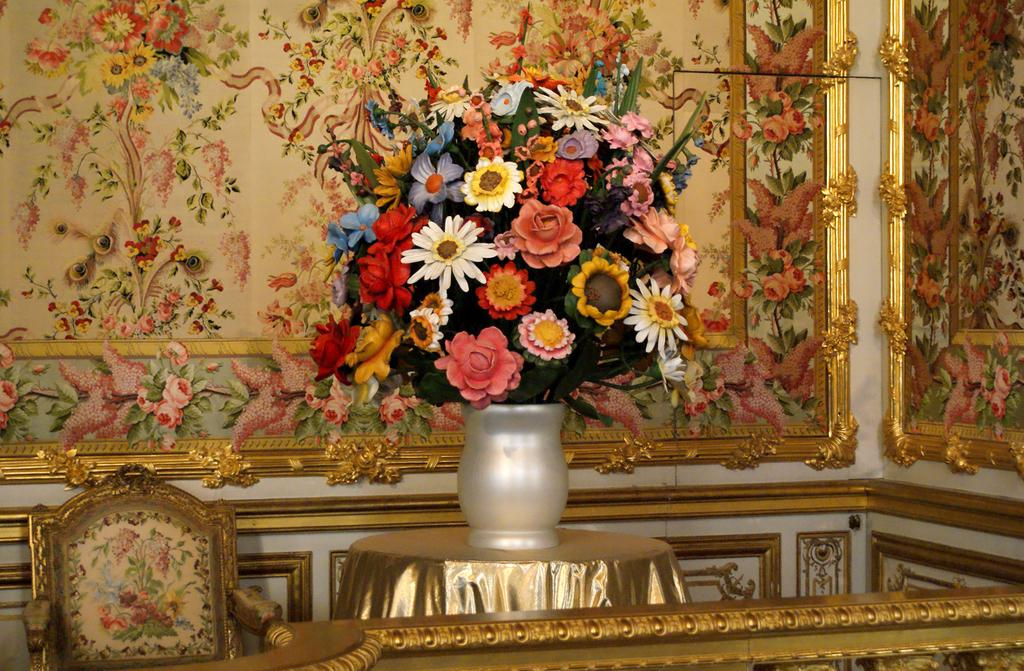What type of furniture is present in the image? There is a chair and a table in the image. What is covering the table in the image? There is a cloth covering the table in the image. What is placed on the table in the image? There is a flower vase on the table in the image. What can be seen in the background of the image? There are frames in the background of the image. What is the purpose of the stomach in the image? There is no stomach present in the image. 